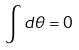<formula> <loc_0><loc_0><loc_500><loc_500>\int d \theta = 0</formula> 